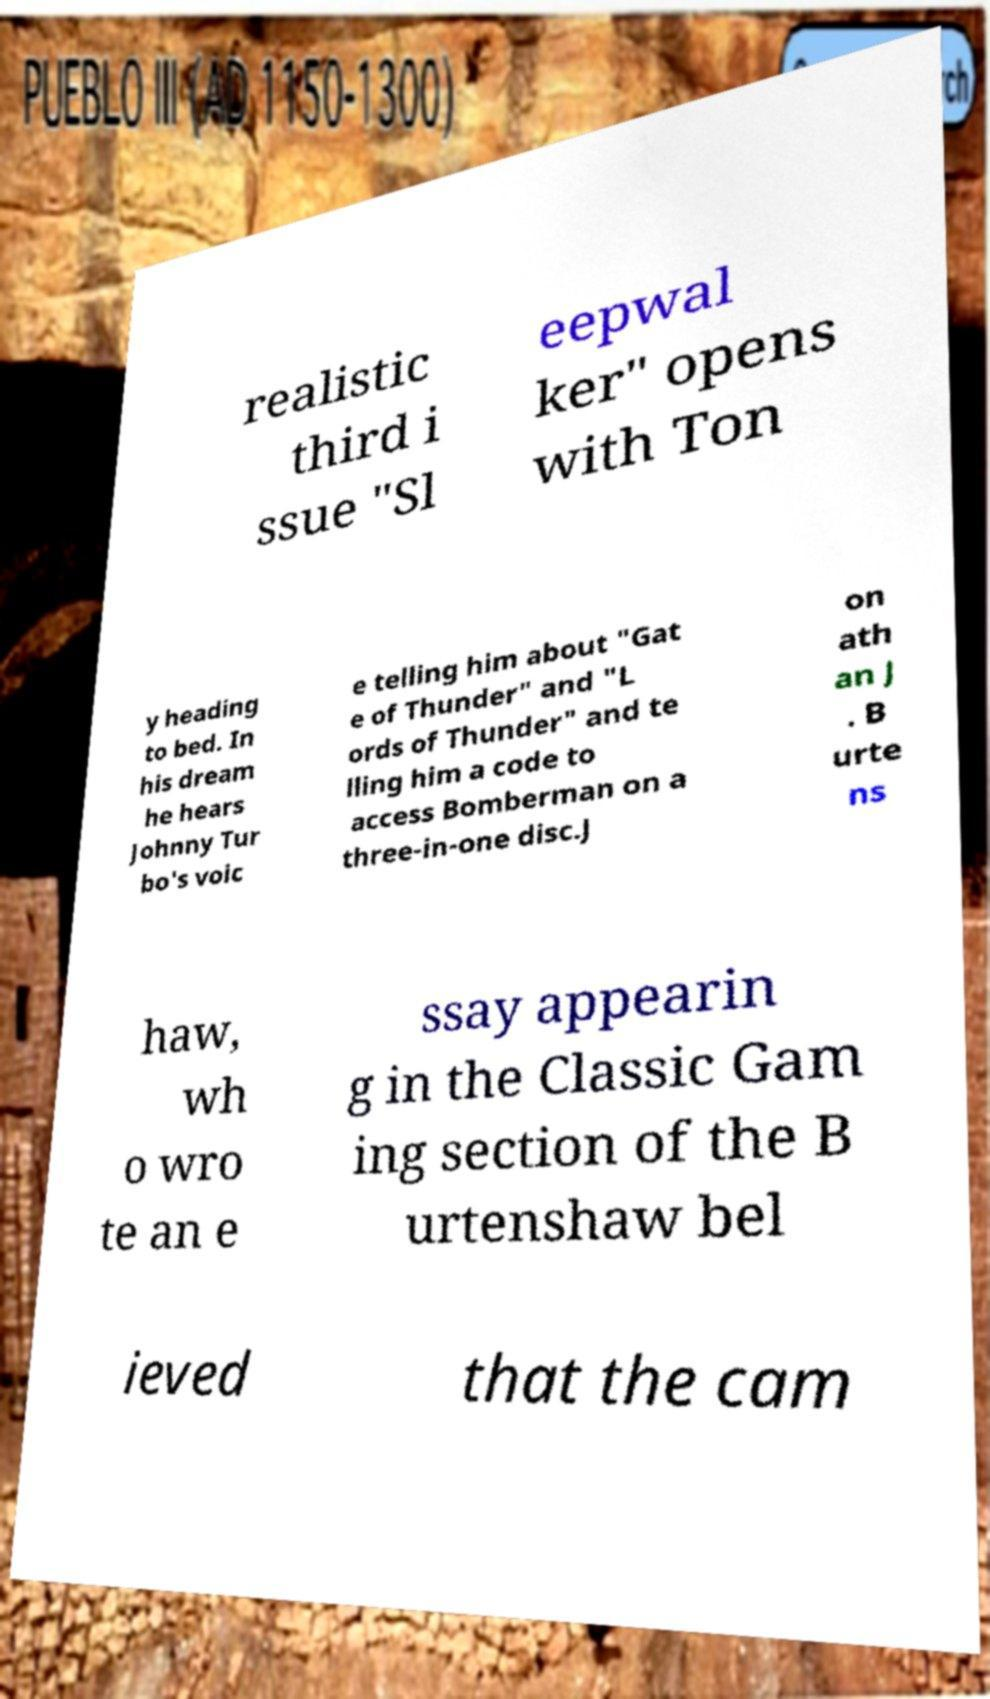There's text embedded in this image that I need extracted. Can you transcribe it verbatim? realistic third i ssue "Sl eepwal ker" opens with Ton y heading to bed. In his dream he hears Johnny Tur bo's voic e telling him about "Gat e of Thunder" and "L ords of Thunder" and te lling him a code to access Bomberman on a three-in-one disc.J on ath an J . B urte ns haw, wh o wro te an e ssay appearin g in the Classic Gam ing section of the B urtenshaw bel ieved that the cam 